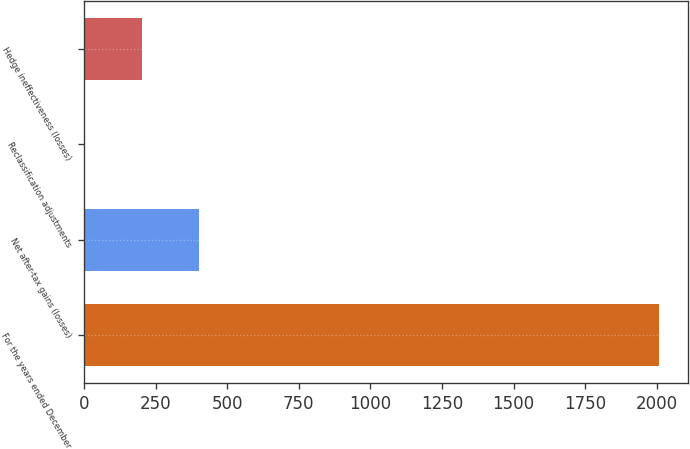Convert chart. <chart><loc_0><loc_0><loc_500><loc_500><bar_chart><fcel>For the years ended December<fcel>Net after-tax gains (losses)<fcel>Reclassification adjustments<fcel>Hedge ineffectiveness (losses)<nl><fcel>2007<fcel>401.56<fcel>0.2<fcel>200.88<nl></chart> 